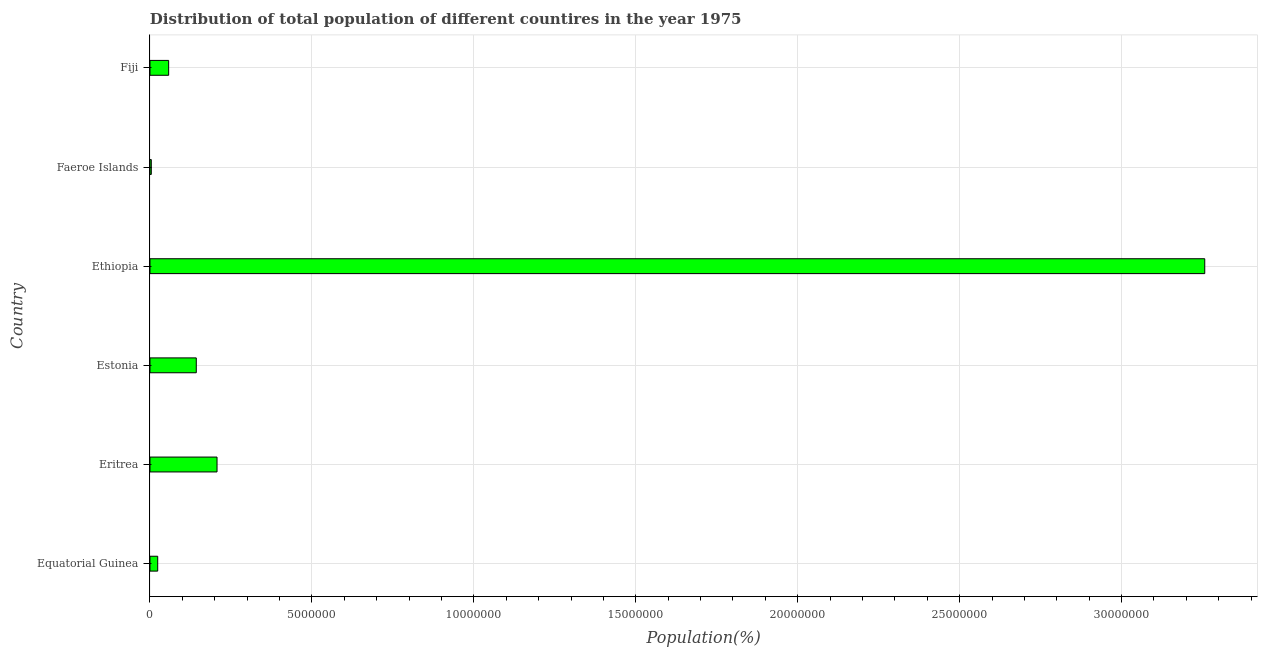Does the graph contain any zero values?
Ensure brevity in your answer.  No. What is the title of the graph?
Offer a very short reply. Distribution of total population of different countires in the year 1975. What is the label or title of the X-axis?
Your answer should be very brief. Population(%). What is the population in Faeroe Islands?
Offer a terse response. 4.05e+04. Across all countries, what is the maximum population?
Provide a succinct answer. 3.26e+07. Across all countries, what is the minimum population?
Keep it short and to the point. 4.05e+04. In which country was the population maximum?
Give a very brief answer. Ethiopia. In which country was the population minimum?
Make the answer very short. Faeroe Islands. What is the sum of the population?
Keep it short and to the point. 3.69e+07. What is the difference between the population in Estonia and Ethiopia?
Provide a short and direct response. -3.11e+07. What is the average population per country?
Keep it short and to the point. 6.15e+06. What is the median population?
Make the answer very short. 1.00e+06. In how many countries, is the population greater than 6000000 %?
Offer a terse response. 1. What is the ratio of the population in Estonia to that in Ethiopia?
Offer a very short reply. 0.04. What is the difference between the highest and the second highest population?
Your response must be concise. 3.05e+07. What is the difference between the highest and the lowest population?
Your answer should be compact. 3.25e+07. How many bars are there?
Offer a very short reply. 6. How many countries are there in the graph?
Make the answer very short. 6. What is the difference between two consecutive major ticks on the X-axis?
Ensure brevity in your answer.  5.00e+06. Are the values on the major ticks of X-axis written in scientific E-notation?
Give a very brief answer. No. What is the Population(%) in Equatorial Guinea?
Ensure brevity in your answer.  2.38e+05. What is the Population(%) in Eritrea?
Ensure brevity in your answer.  2.07e+06. What is the Population(%) of Estonia?
Give a very brief answer. 1.43e+06. What is the Population(%) in Ethiopia?
Your response must be concise. 3.26e+07. What is the Population(%) in Faeroe Islands?
Make the answer very short. 4.05e+04. What is the Population(%) in Fiji?
Provide a short and direct response. 5.77e+05. What is the difference between the Population(%) in Equatorial Guinea and Eritrea?
Your response must be concise. -1.83e+06. What is the difference between the Population(%) in Equatorial Guinea and Estonia?
Ensure brevity in your answer.  -1.19e+06. What is the difference between the Population(%) in Equatorial Guinea and Ethiopia?
Keep it short and to the point. -3.23e+07. What is the difference between the Population(%) in Equatorial Guinea and Faeroe Islands?
Your answer should be very brief. 1.98e+05. What is the difference between the Population(%) in Equatorial Guinea and Fiji?
Ensure brevity in your answer.  -3.38e+05. What is the difference between the Population(%) in Eritrea and Estonia?
Offer a very short reply. 6.41e+05. What is the difference between the Population(%) in Eritrea and Ethiopia?
Keep it short and to the point. -3.05e+07. What is the difference between the Population(%) in Eritrea and Faeroe Islands?
Ensure brevity in your answer.  2.03e+06. What is the difference between the Population(%) in Eritrea and Fiji?
Your answer should be very brief. 1.49e+06. What is the difference between the Population(%) in Estonia and Ethiopia?
Offer a very short reply. -3.11e+07. What is the difference between the Population(%) in Estonia and Faeroe Islands?
Your answer should be very brief. 1.39e+06. What is the difference between the Population(%) in Estonia and Fiji?
Offer a terse response. 8.53e+05. What is the difference between the Population(%) in Ethiopia and Faeroe Islands?
Your response must be concise. 3.25e+07. What is the difference between the Population(%) in Ethiopia and Fiji?
Give a very brief answer. 3.20e+07. What is the difference between the Population(%) in Faeroe Islands and Fiji?
Your answer should be compact. -5.36e+05. What is the ratio of the Population(%) in Equatorial Guinea to that in Eritrea?
Make the answer very short. 0.12. What is the ratio of the Population(%) in Equatorial Guinea to that in Estonia?
Give a very brief answer. 0.17. What is the ratio of the Population(%) in Equatorial Guinea to that in Ethiopia?
Keep it short and to the point. 0.01. What is the ratio of the Population(%) in Equatorial Guinea to that in Faeroe Islands?
Make the answer very short. 5.88. What is the ratio of the Population(%) in Equatorial Guinea to that in Fiji?
Offer a very short reply. 0.41. What is the ratio of the Population(%) in Eritrea to that in Estonia?
Make the answer very short. 1.45. What is the ratio of the Population(%) in Eritrea to that in Ethiopia?
Your answer should be compact. 0.06. What is the ratio of the Population(%) in Eritrea to that in Faeroe Islands?
Your response must be concise. 51.08. What is the ratio of the Population(%) in Eritrea to that in Fiji?
Make the answer very short. 3.59. What is the ratio of the Population(%) in Estonia to that in Ethiopia?
Offer a very short reply. 0.04. What is the ratio of the Population(%) in Estonia to that in Faeroe Islands?
Offer a very short reply. 35.27. What is the ratio of the Population(%) in Estonia to that in Fiji?
Offer a very short reply. 2.48. What is the ratio of the Population(%) in Ethiopia to that in Faeroe Islands?
Make the answer very short. 803.59. What is the ratio of the Population(%) in Ethiopia to that in Fiji?
Offer a terse response. 56.48. What is the ratio of the Population(%) in Faeroe Islands to that in Fiji?
Keep it short and to the point. 0.07. 